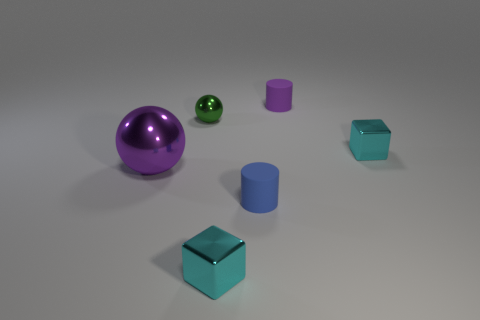Could you describe the lighting and shadows in the scene? The lighting in the image is diffused, creating soft shadows on the ground below each object. The direction of the light source is not directly visible, but it seems to be coming from the upper left side based on the shadows cast. 